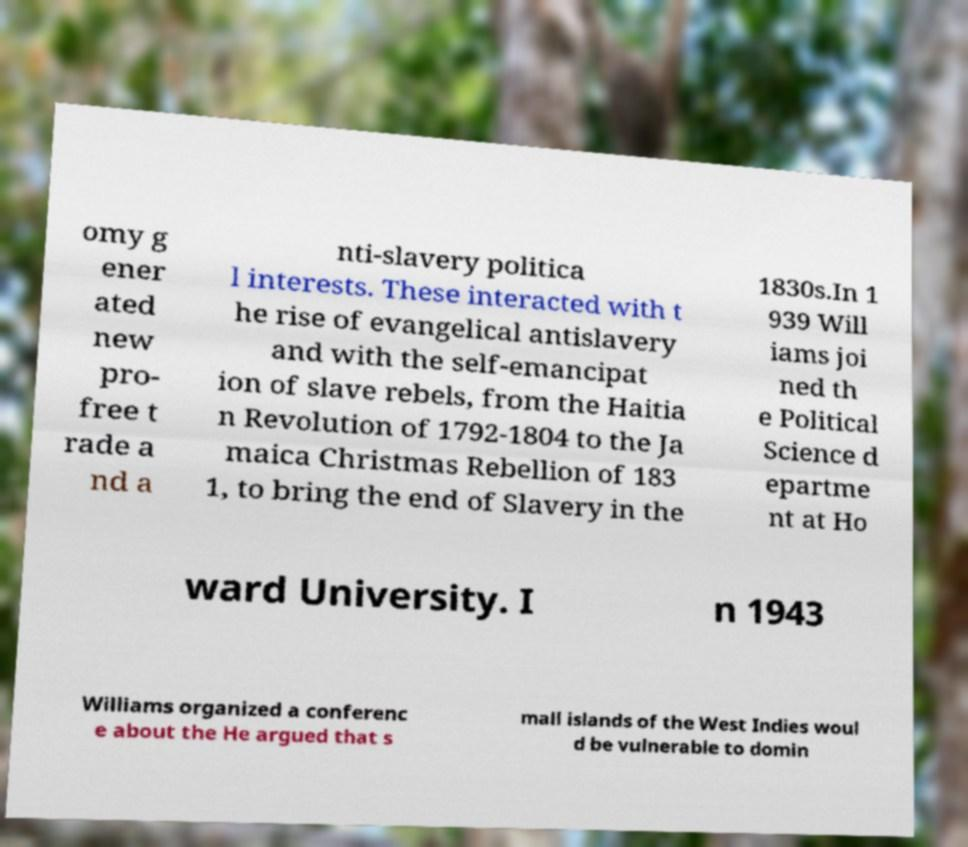There's text embedded in this image that I need extracted. Can you transcribe it verbatim? omy g ener ated new pro- free t rade a nd a nti-slavery politica l interests. These interacted with t he rise of evangelical antislavery and with the self-emancipat ion of slave rebels, from the Haitia n Revolution of 1792-1804 to the Ja maica Christmas Rebellion of 183 1, to bring the end of Slavery in the 1830s.In 1 939 Will iams joi ned th e Political Science d epartme nt at Ho ward University. I n 1943 Williams organized a conferenc e about the He argued that s mall islands of the West Indies woul d be vulnerable to domin 